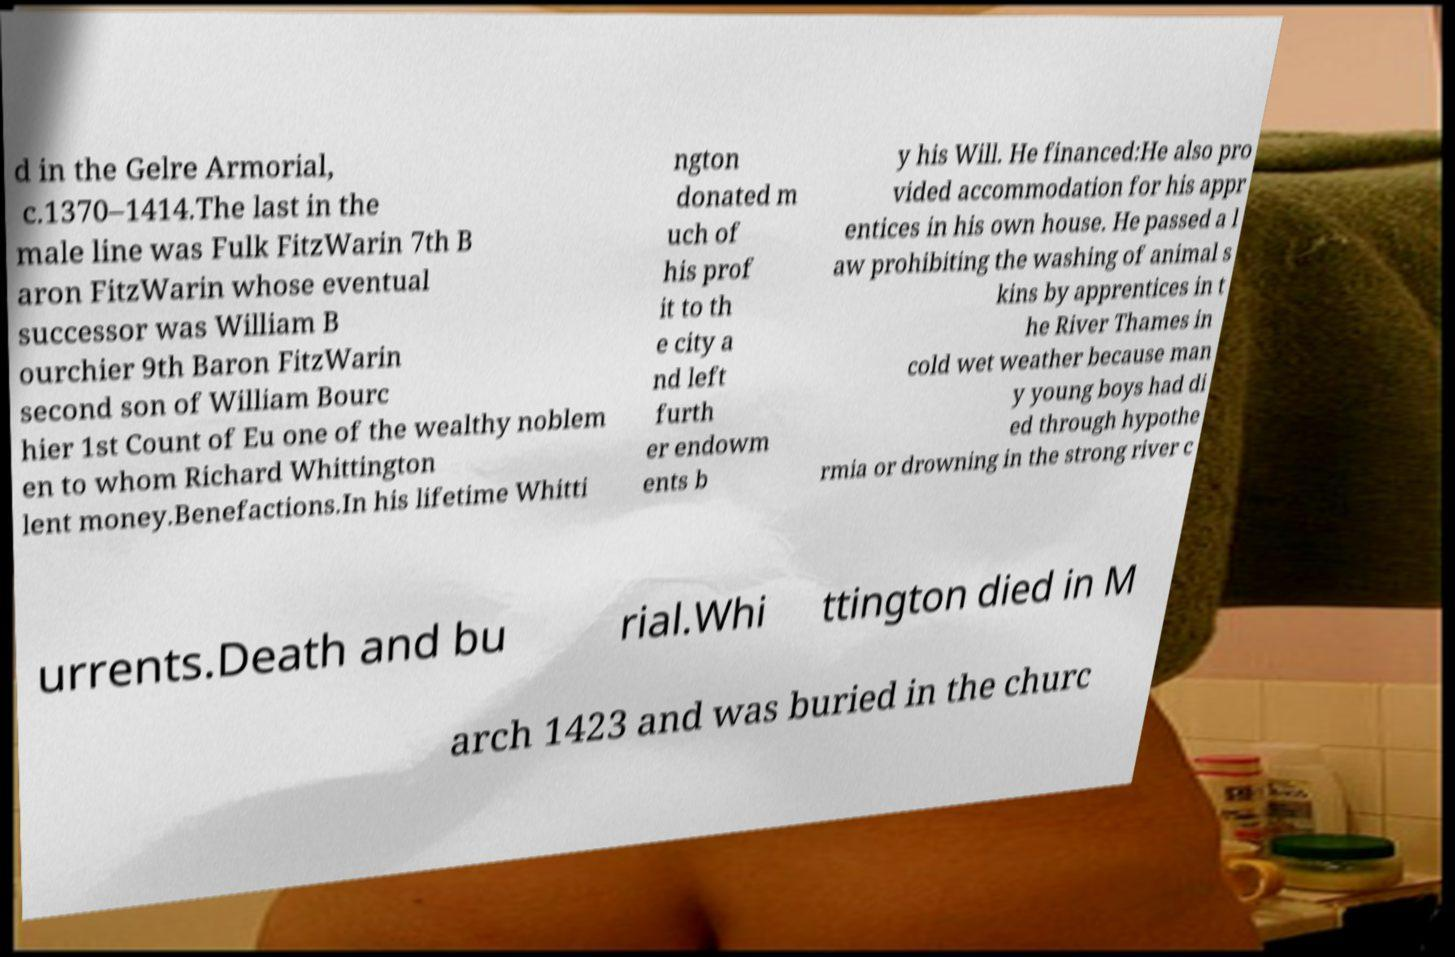Can you accurately transcribe the text from the provided image for me? d in the Gelre Armorial, c.1370–1414.The last in the male line was Fulk FitzWarin 7th B aron FitzWarin whose eventual successor was William B ourchier 9th Baron FitzWarin second son of William Bourc hier 1st Count of Eu one of the wealthy noblem en to whom Richard Whittington lent money.Benefactions.In his lifetime Whitti ngton donated m uch of his prof it to th e city a nd left furth er endowm ents b y his Will. He financed:He also pro vided accommodation for his appr entices in his own house. He passed a l aw prohibiting the washing of animal s kins by apprentices in t he River Thames in cold wet weather because man y young boys had di ed through hypothe rmia or drowning in the strong river c urrents.Death and bu rial.Whi ttington died in M arch 1423 and was buried in the churc 